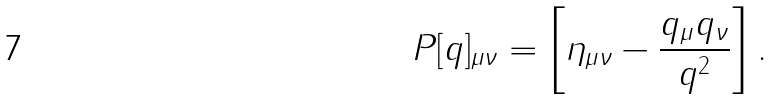Convert formula to latex. <formula><loc_0><loc_0><loc_500><loc_500>P [ q ] _ { \mu \nu } = \left [ \eta _ { \mu \nu } - \frac { q _ { \mu } q _ { \nu } } { q ^ { 2 } } \right ] .</formula> 